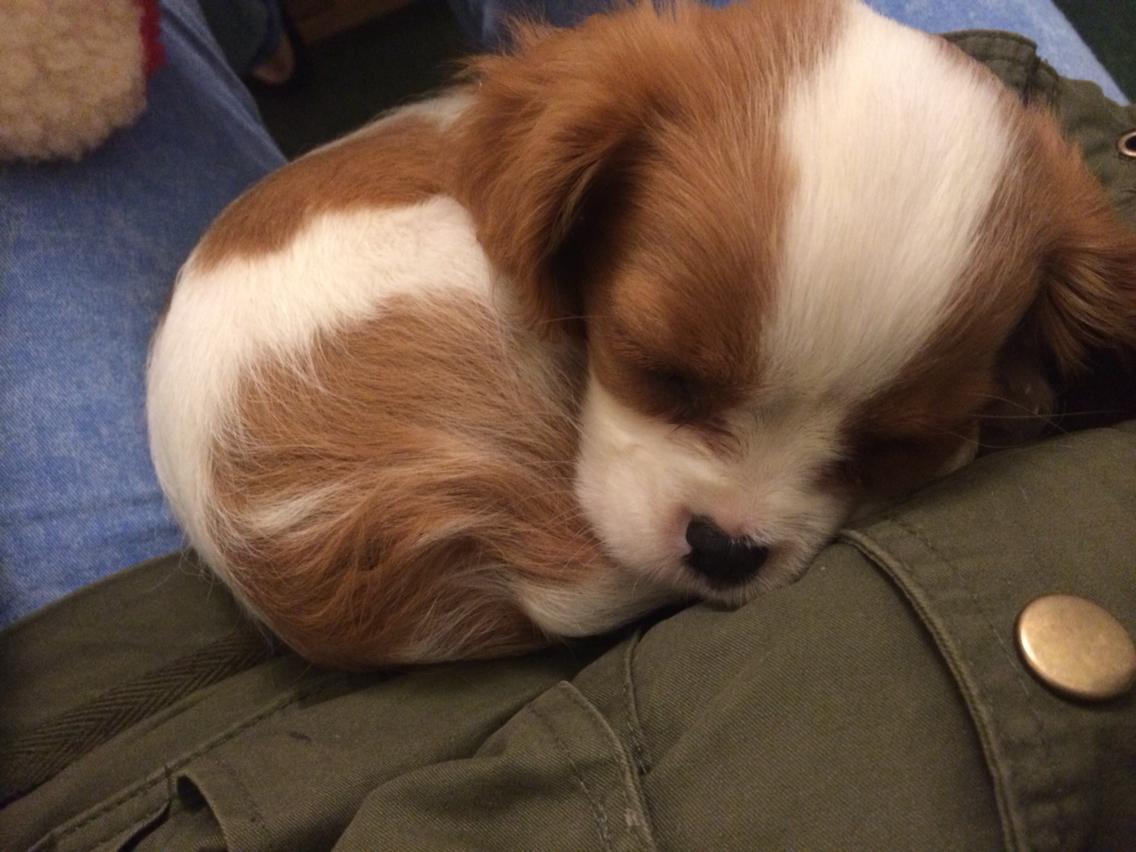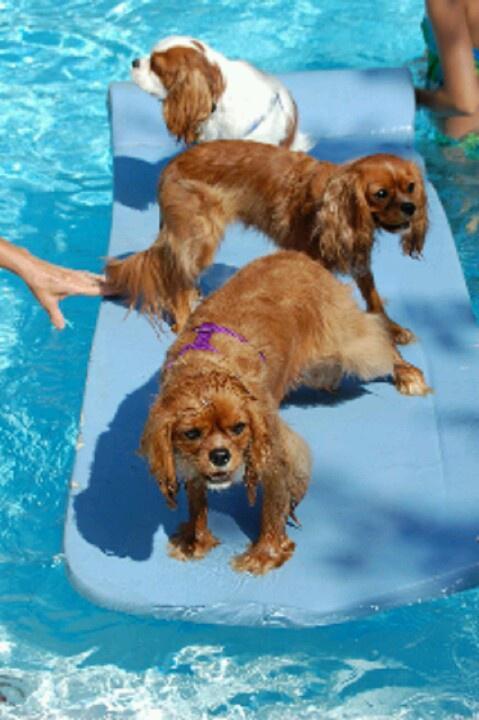The first image is the image on the left, the second image is the image on the right. For the images shown, is this caption "At least one image shows a spaniel on a solid blue background, and at least one image shows a spaniel gazing upward and to the left." true? Answer yes or no. No. The first image is the image on the left, the second image is the image on the right. Considering the images on both sides, is "Part of a human is visible in at least one of the images." valid? Answer yes or no. Yes. 